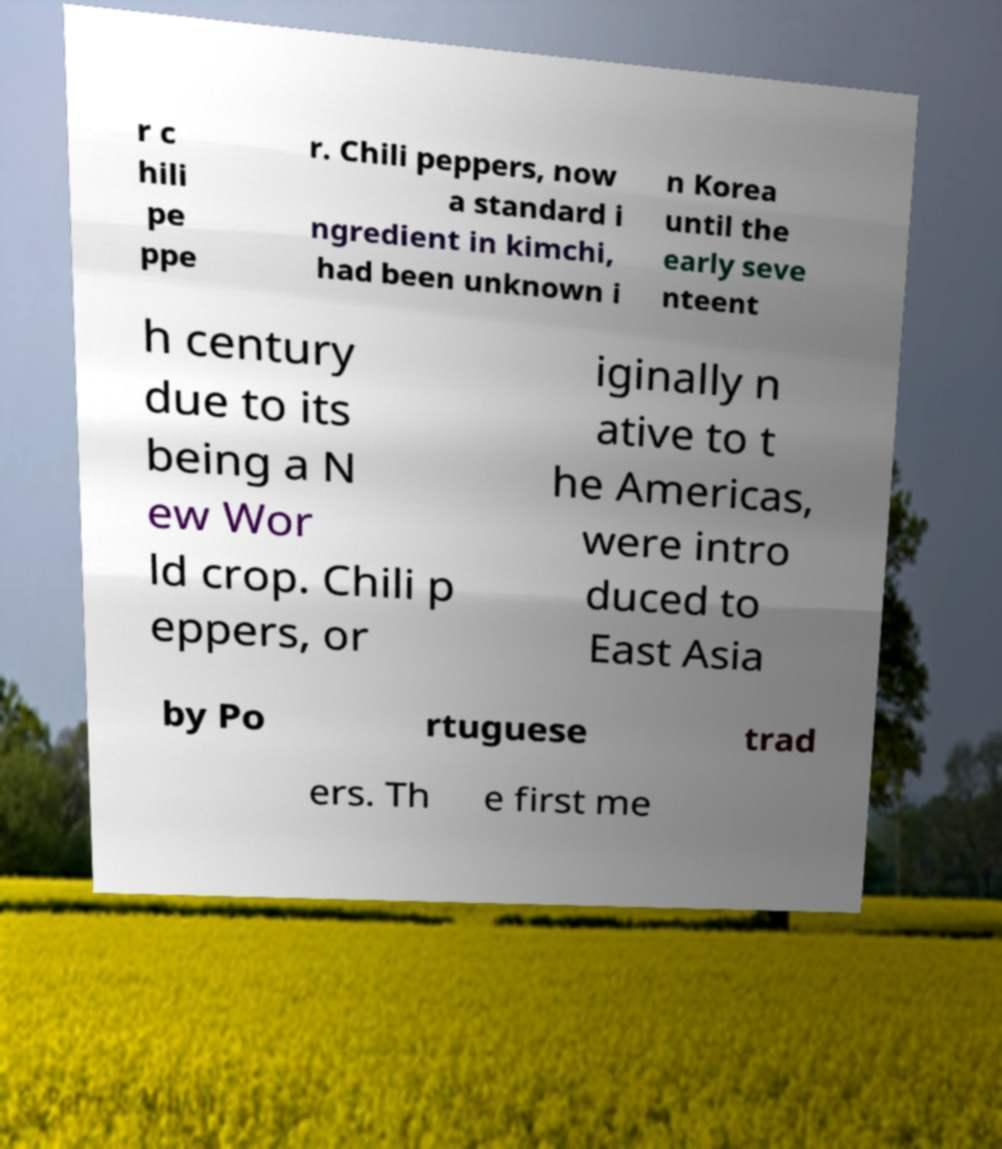Can you accurately transcribe the text from the provided image for me? r c hili pe ppe r. Chili peppers, now a standard i ngredient in kimchi, had been unknown i n Korea until the early seve nteent h century due to its being a N ew Wor ld crop. Chili p eppers, or iginally n ative to t he Americas, were intro duced to East Asia by Po rtuguese trad ers. Th e first me 